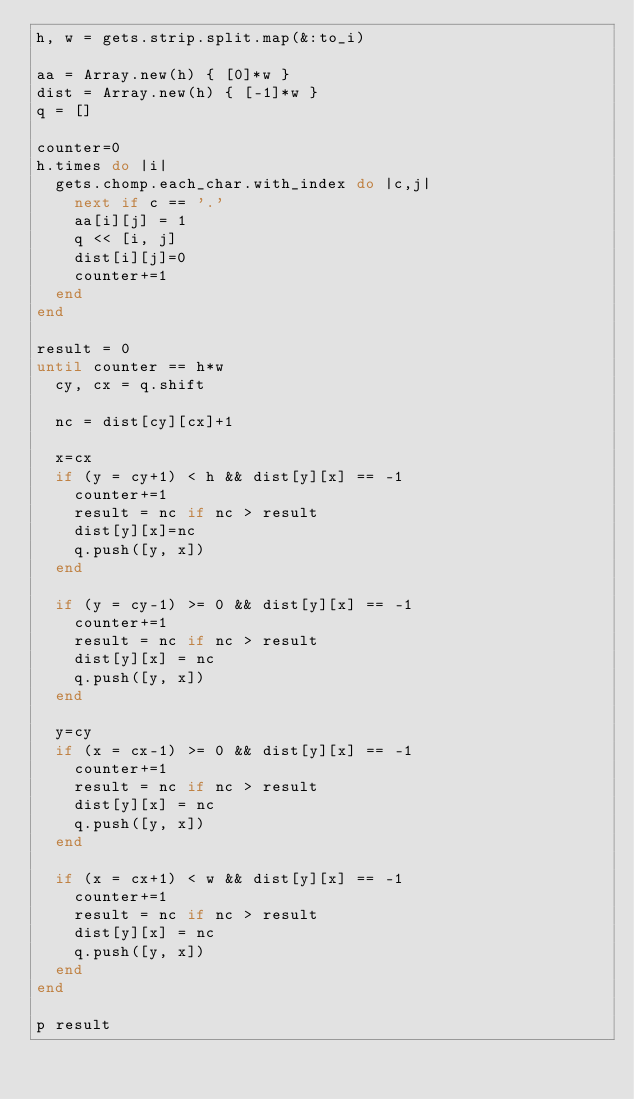<code> <loc_0><loc_0><loc_500><loc_500><_Ruby_>h, w = gets.strip.split.map(&:to_i)

aa = Array.new(h) { [0]*w }
dist = Array.new(h) { [-1]*w }
q = []

counter=0
h.times do |i|
  gets.chomp.each_char.with_index do |c,j|
    next if c == '.'
    aa[i][j] = 1
    q << [i, j]
    dist[i][j]=0
    counter+=1
  end
end

result = 0
until counter == h*w
  cy, cx = q.shift

  nc = dist[cy][cx]+1

  x=cx
  if (y = cy+1) < h && dist[y][x] == -1
    counter+=1
    result = nc if nc > result
    dist[y][x]=nc
    q.push([y, x])
  end

  if (y = cy-1) >= 0 && dist[y][x] == -1
    counter+=1
    result = nc if nc > result
    dist[y][x] = nc
    q.push([y, x])
  end

  y=cy
  if (x = cx-1) >= 0 && dist[y][x] == -1
    counter+=1
    result = nc if nc > result
    dist[y][x] = nc
    q.push([y, x])
  end

  if (x = cx+1) < w && dist[y][x] == -1
    counter+=1
    result = nc if nc > result
    dist[y][x] = nc
    q.push([y, x])
  end
end

p result
</code> 